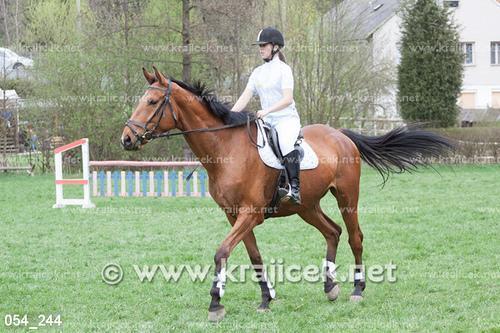How many horses?
Give a very brief answer. 1. 